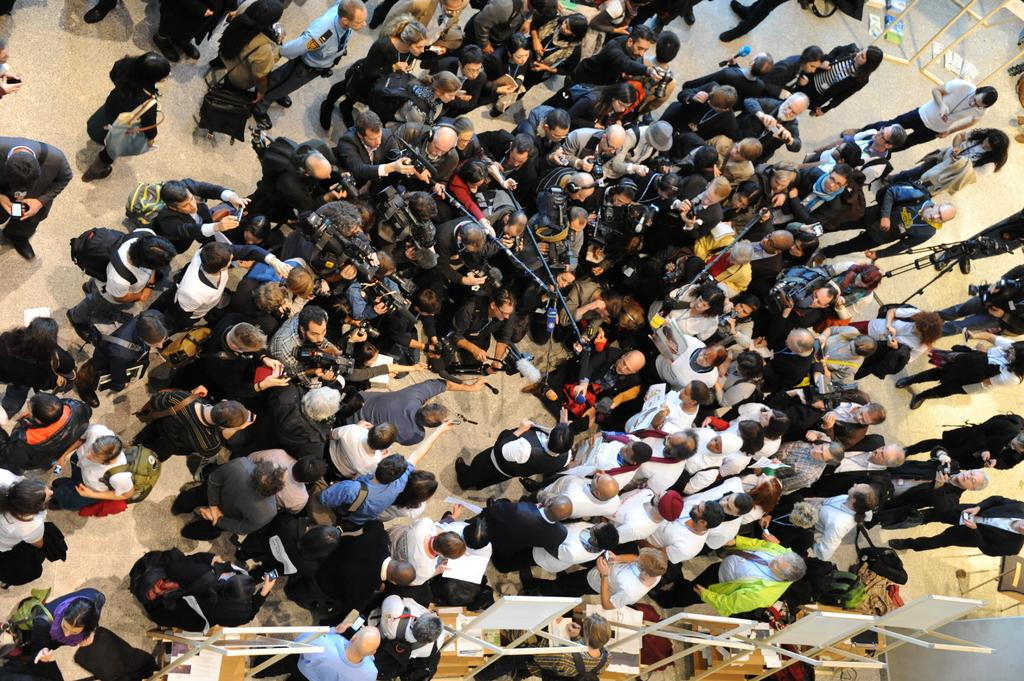How many people are in the image? There is a group of people in the image. What are the people wearing? The people are wearing different color dresses. What are two people holding in the image? Two people are holding sticks. What can be seen on the tables in the image? There are boards on the tables. Who is the writer in the image? There is no writer present in the image. What type of reward can be seen on the boards? There is no reward visible on the boards; they are simply boards on the tables. 